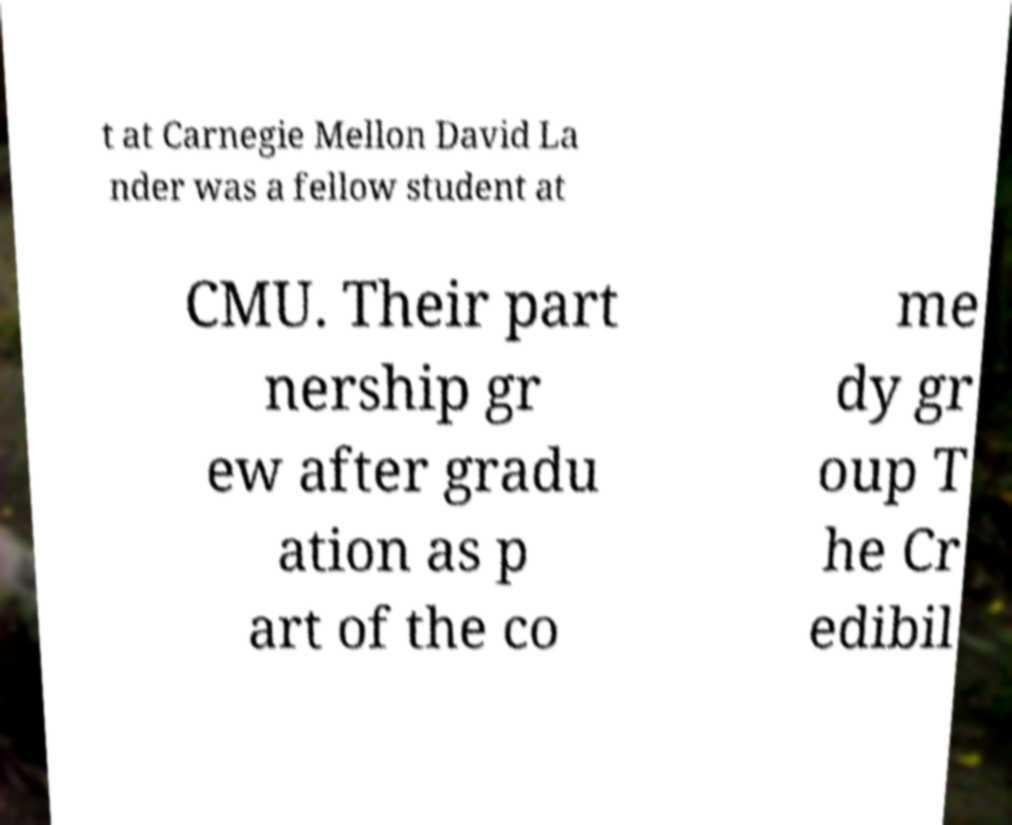Please read and relay the text visible in this image. What does it say? t at Carnegie Mellon David La nder was a fellow student at CMU. Their part nership gr ew after gradu ation as p art of the co me dy gr oup T he Cr edibil 